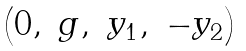Convert formula to latex. <formula><loc_0><loc_0><loc_500><loc_500>\begin{pmatrix} 0 , & g , & y _ { 1 } , & - y _ { 2 } \end{pmatrix}</formula> 